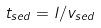<formula> <loc_0><loc_0><loc_500><loc_500>t _ { s e d } = l / v _ { s e d }</formula> 